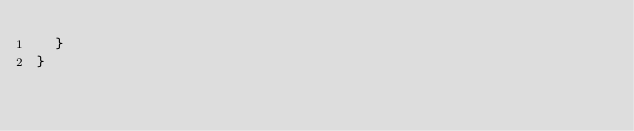Convert code to text. <code><loc_0><loc_0><loc_500><loc_500><_TypeScript_>  }
}
</code> 